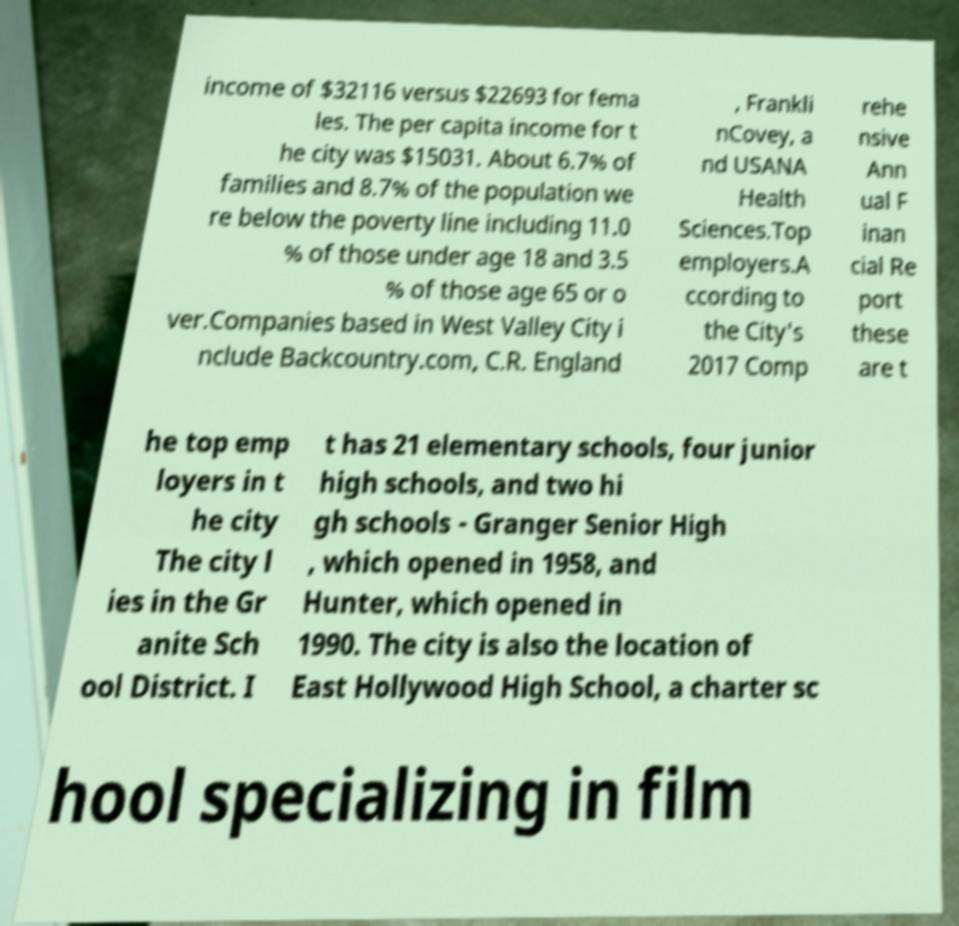Please read and relay the text visible in this image. What does it say? income of $32116 versus $22693 for fema les. The per capita income for t he city was $15031. About 6.7% of families and 8.7% of the population we re below the poverty line including 11.0 % of those under age 18 and 3.5 % of those age 65 or o ver.Companies based in West Valley City i nclude Backcountry.com, C.R. England , Frankli nCovey, a nd USANA Health Sciences.Top employers.A ccording to the City's 2017 Comp rehe nsive Ann ual F inan cial Re port these are t he top emp loyers in t he city The city l ies in the Gr anite Sch ool District. I t has 21 elementary schools, four junior high schools, and two hi gh schools - Granger Senior High , which opened in 1958, and Hunter, which opened in 1990. The city is also the location of East Hollywood High School, a charter sc hool specializing in film 